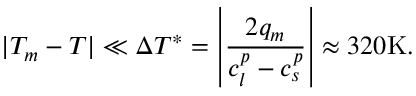Convert formula to latex. <formula><loc_0><loc_0><loc_500><loc_500>| T _ { m } - T | \ll \Delta T ^ { * } = \left | \frac { 2 q _ { m } } { c _ { l } ^ { p } - c _ { s } ^ { p } } \right | \approx 3 2 0 K .</formula> 